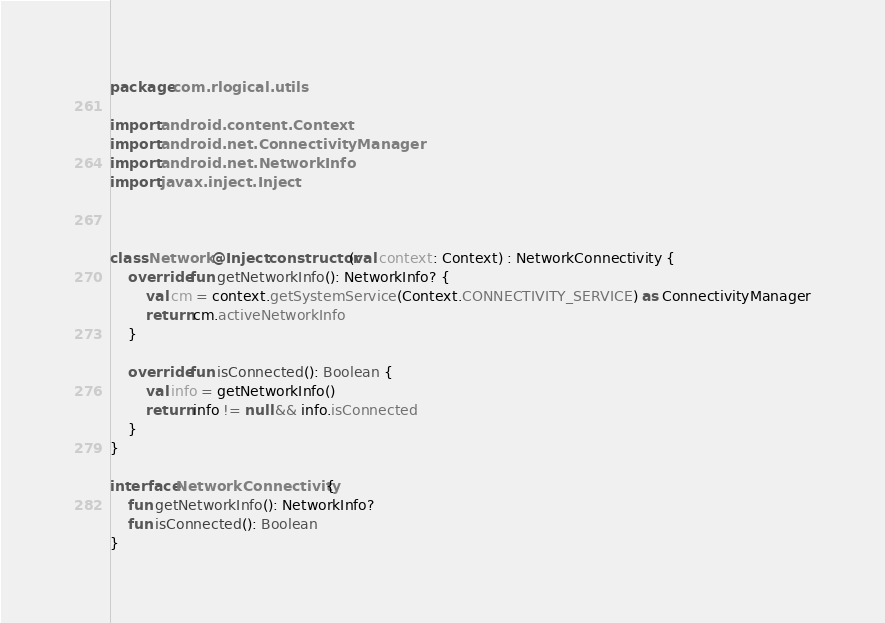<code> <loc_0><loc_0><loc_500><loc_500><_Kotlin_>package com.rlogical.utils

import android.content.Context
import android.net.ConnectivityManager
import android.net.NetworkInfo
import javax.inject.Inject



class Network @Inject constructor(val context: Context) : NetworkConnectivity {
    override fun getNetworkInfo(): NetworkInfo? {
        val cm = context.getSystemService(Context.CONNECTIVITY_SERVICE) as ConnectivityManager
        return cm.activeNetworkInfo
    }

    override fun isConnected(): Boolean {
        val info = getNetworkInfo()
        return info != null && info.isConnected
    }
}

interface NetworkConnectivity {
    fun getNetworkInfo(): NetworkInfo?
    fun isConnected(): Boolean
}</code> 